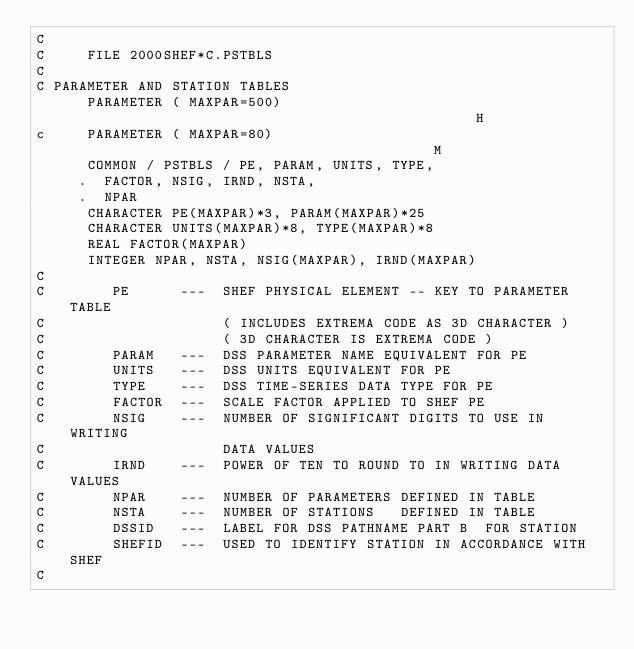Convert code to text. <code><loc_0><loc_0><loc_500><loc_500><_C_>C
C     FILE 2000SHEF*C.PSTBLS
C
C PARAMETER AND STATION TABLES
      PARAMETER ( MAXPAR=500)                                           H
c     PARAMETER ( MAXPAR=80)                                            M
      COMMON / PSTBLS / PE, PARAM, UNITS, TYPE,
     .  FACTOR, NSIG, IRND, NSTA,
     .  NPAR
      CHARACTER PE(MAXPAR)*3, PARAM(MAXPAR)*25
      CHARACTER UNITS(MAXPAR)*8, TYPE(MAXPAR)*8
      REAL FACTOR(MAXPAR)
      INTEGER NPAR, NSTA, NSIG(MAXPAR), IRND(MAXPAR)
C
C        PE      ---  SHEF PHYSICAL ELEMENT -- KEY TO PARAMETER TABLE
C                     ( INCLUDES EXTREMA CODE AS 3D CHARACTER )
C                     ( 3D CHARACTER IS EXTREMA CODE )
C        PARAM   ---  DSS PARAMETER NAME EQUIVALENT FOR PE
C        UNITS   ---  DSS UNITS EQUIVALENT FOR PE
C        TYPE    ---  DSS TIME-SERIES DATA TYPE FOR PE
C        FACTOR  ---  SCALE FACTOR APPLIED TO SHEF PE
C        NSIG    ---  NUMBER OF SIGNIFICANT DIGITS TO USE IN WRITING
C                     DATA VALUES
C        IRND    ---  POWER OF TEN TO ROUND TO IN WRITING DATA VALUES
C        NPAR    ---  NUMBER OF PARAMETERS DEFINED IN TABLE
C        NSTA    ---  NUMBER OF STATIONS   DEFINED IN TABLE
C        DSSID   ---  LABEL FOR DSS PATHNAME PART B  FOR STATION
C        SHEFID  ---  USED TO IDENTIFY STATION IN ACCORDANCE WITH SHEF
C
</code> 